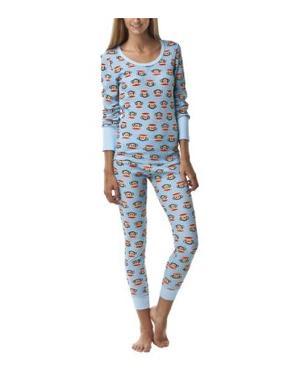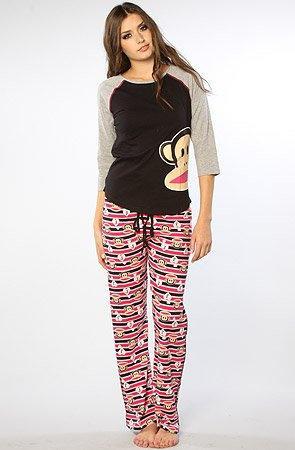The first image is the image on the left, the second image is the image on the right. Analyze the images presented: Is the assertion "Pajama shirts in both images have sleeves the same length." valid? Answer yes or no. Yes. The first image is the image on the left, the second image is the image on the right. For the images displayed, is the sentence "Right image shows a girl in a jersey-type shirt with one monkey image on front." factually correct? Answer yes or no. Yes. 